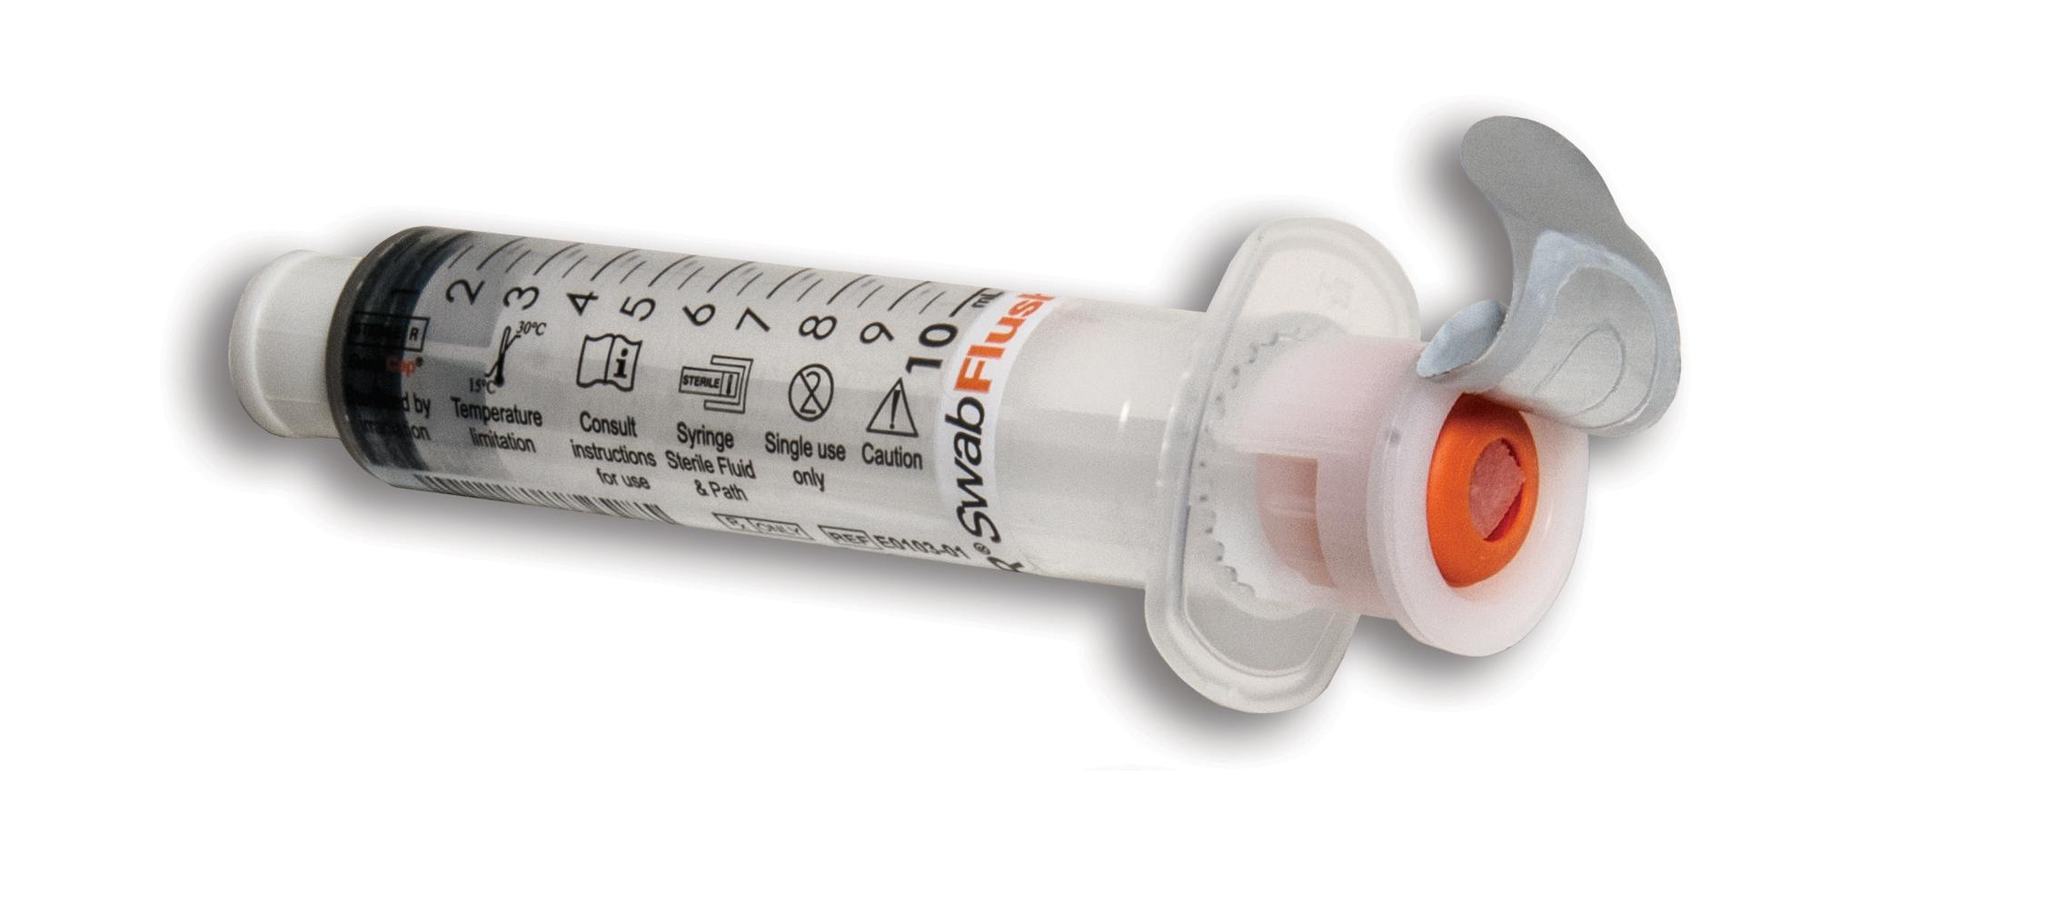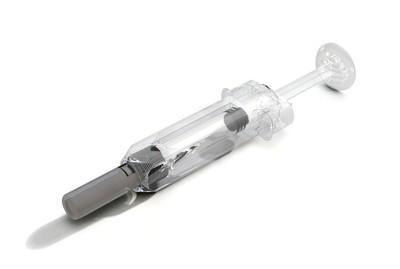The first image is the image on the left, the second image is the image on the right. Assess this claim about the two images: "In one image, the sharp end of a needle is enclosed in a cone-shaped plastic tip.". Correct or not? Answer yes or no. No. 